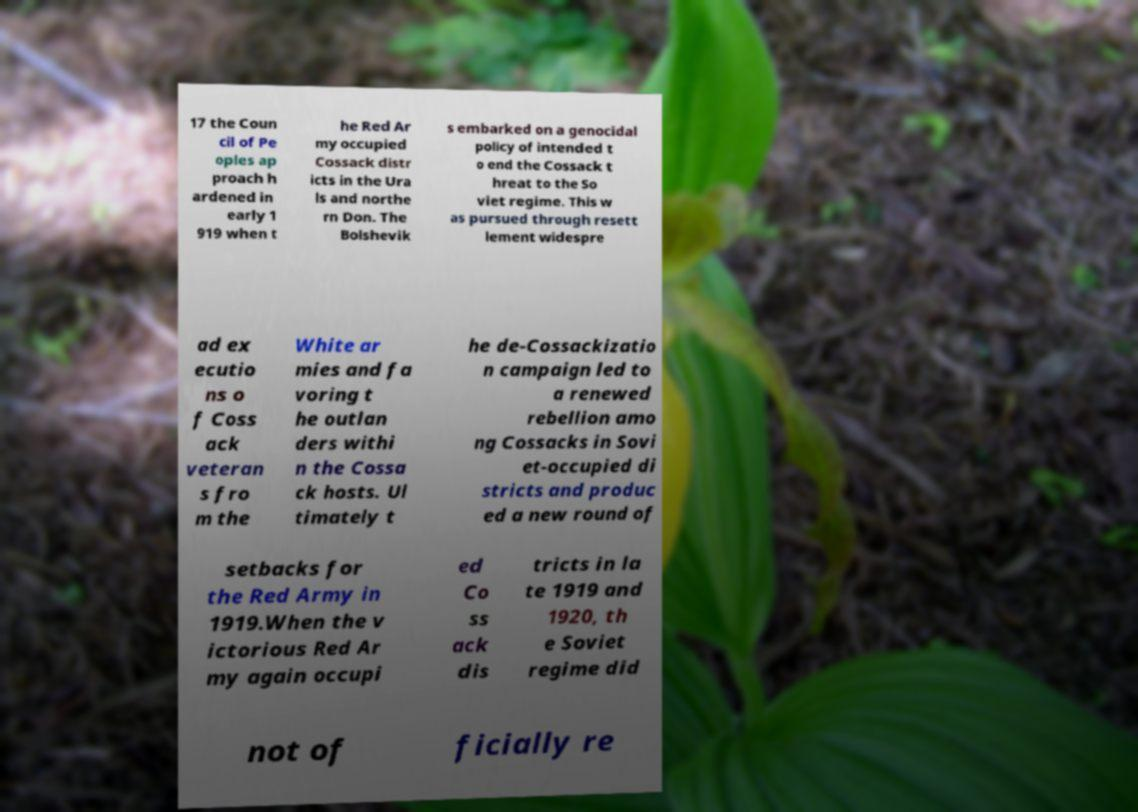Can you accurately transcribe the text from the provided image for me? 17 the Coun cil of Pe oples ap proach h ardened in early 1 919 when t he Red Ar my occupied Cossack distr icts in the Ura ls and northe rn Don. The Bolshevik s embarked on a genocidal policy of intended t o end the Cossack t hreat to the So viet regime. This w as pursued through resett lement widespre ad ex ecutio ns o f Coss ack veteran s fro m the White ar mies and fa voring t he outlan ders withi n the Cossa ck hosts. Ul timately t he de-Cossackizatio n campaign led to a renewed rebellion amo ng Cossacks in Sovi et-occupied di stricts and produc ed a new round of setbacks for the Red Army in 1919.When the v ictorious Red Ar my again occupi ed Co ss ack dis tricts in la te 1919 and 1920, th e Soviet regime did not of ficially re 